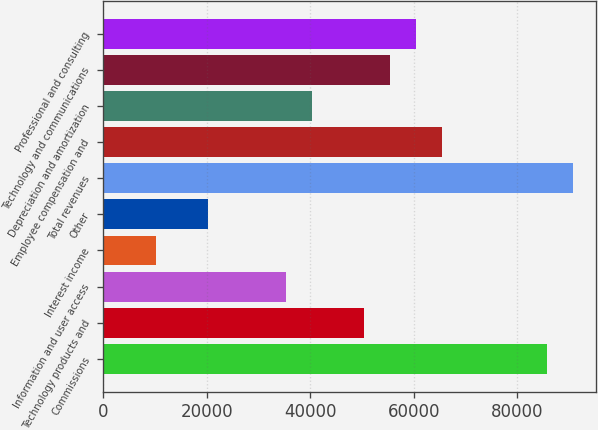<chart> <loc_0><loc_0><loc_500><loc_500><bar_chart><fcel>Commissions<fcel>Technology products and<fcel>Information and user access<fcel>Interest income<fcel>Other<fcel>Total revenues<fcel>Employee compensation and<fcel>Depreciation and amortization<fcel>Technology and communications<fcel>Professional and consulting<nl><fcel>85657.6<fcel>50387<fcel>35271.1<fcel>10077.8<fcel>20155.1<fcel>90696.2<fcel>65503<fcel>40309.7<fcel>55425.7<fcel>60464.3<nl></chart> 